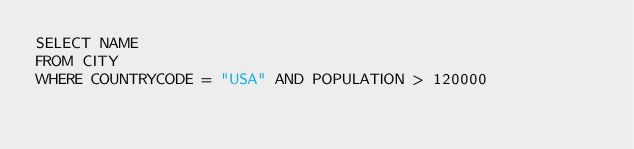<code> <loc_0><loc_0><loc_500><loc_500><_SQL_>SELECT NAME
FROM CITY
WHERE COUNTRYCODE = "USA" AND POPULATION > 120000</code> 